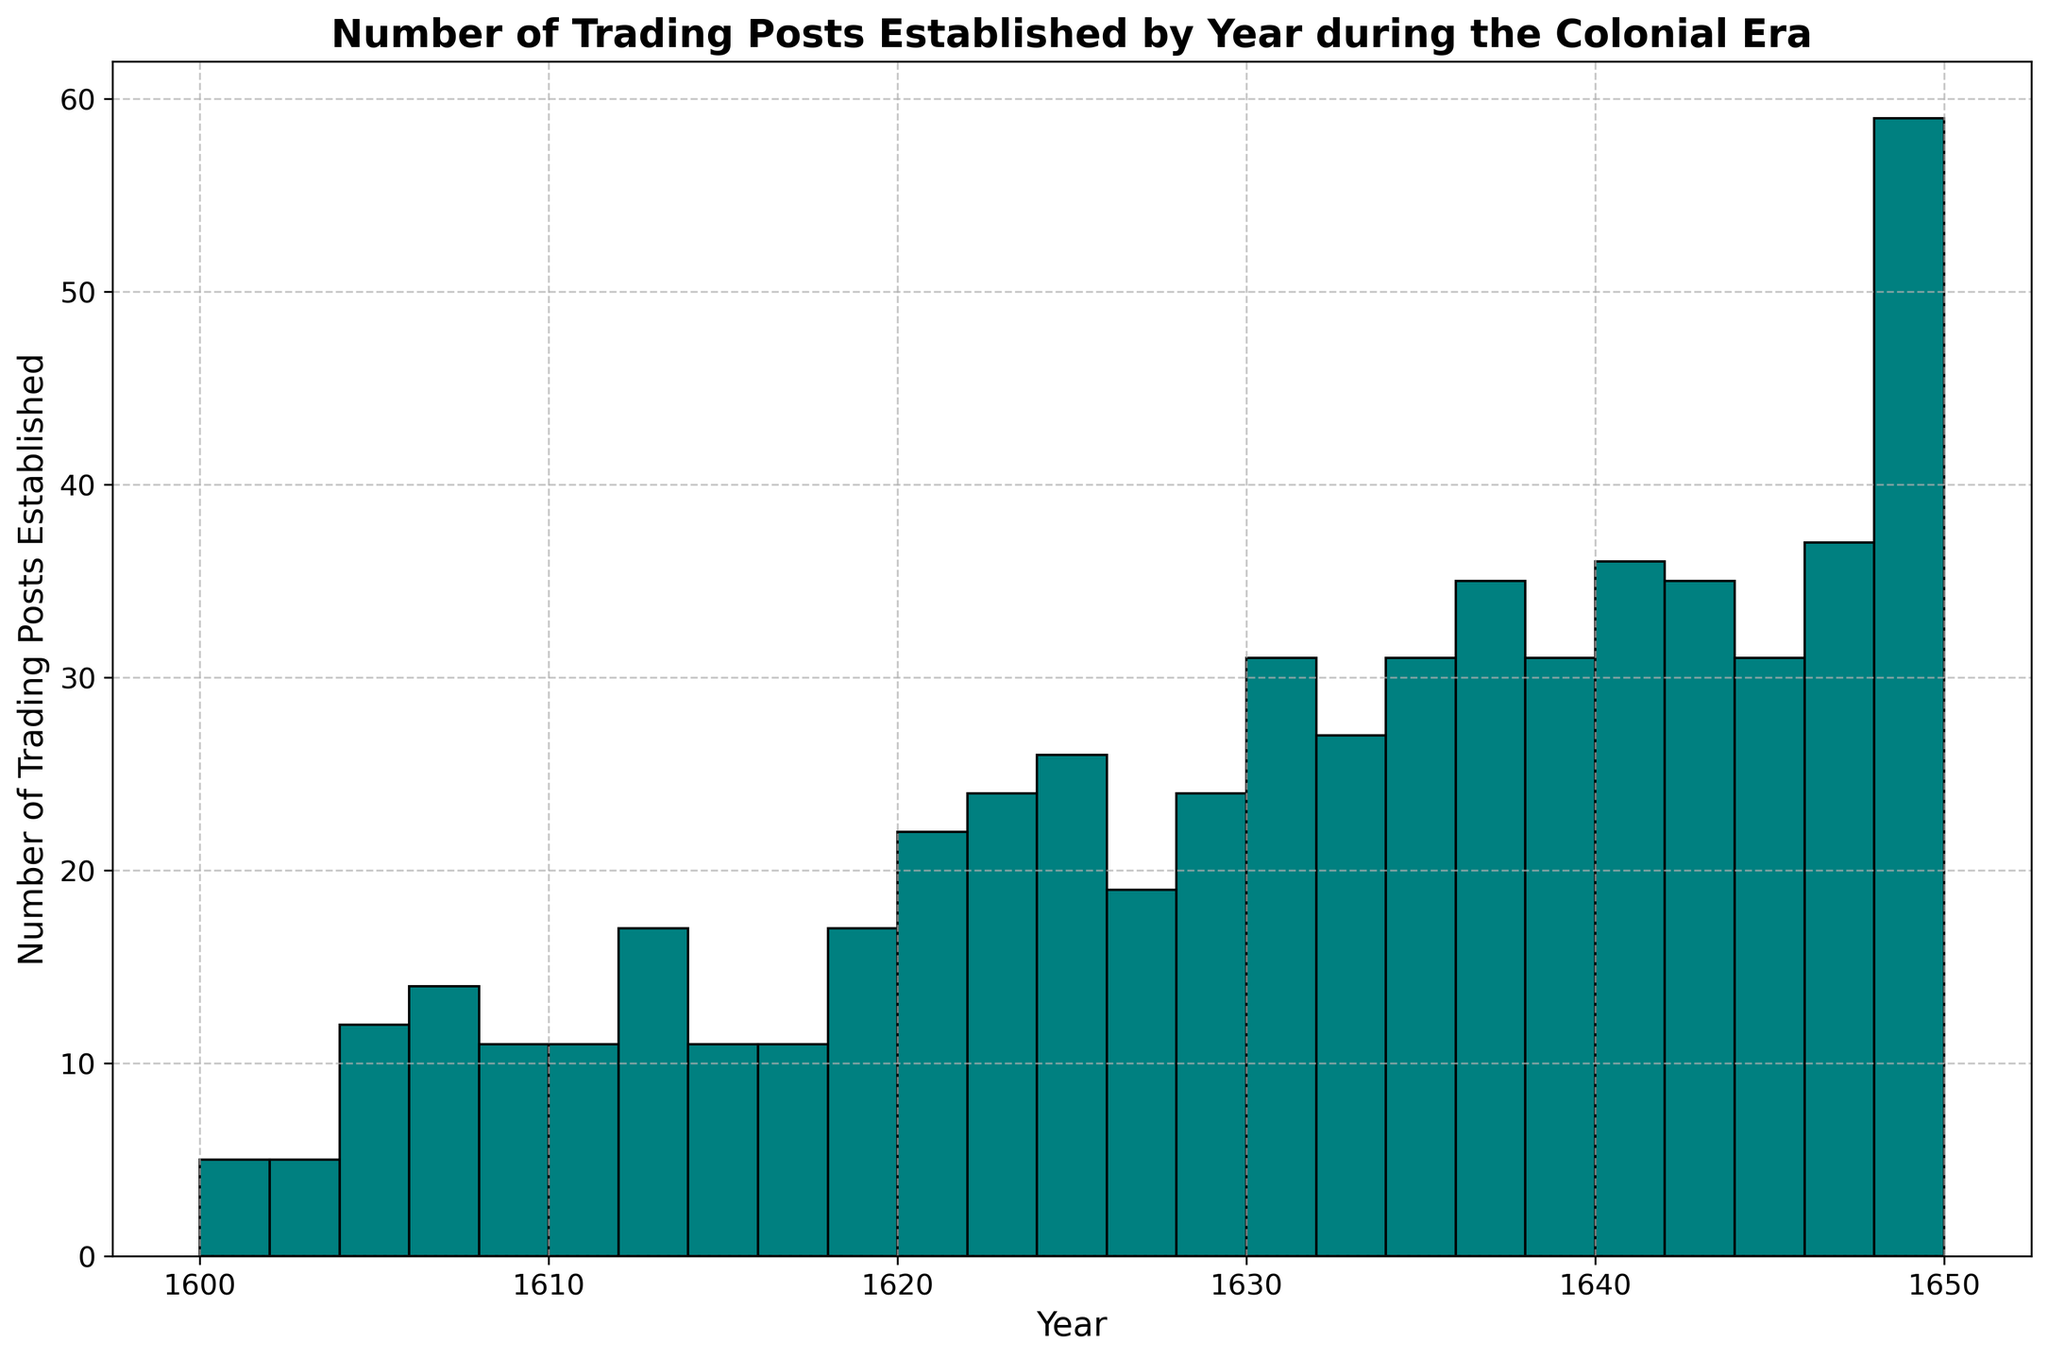What's the peak year for the establishment of trading posts? The histogram will show the year with the highest number of trading posts established, which appears as the tallest bar. This occurs around 1650.
Answer: 1650 Which year had the fewest number of trading posts established, and how many were established? The histogram displays the different bar heights representing the count of trading posts for each year. The shortest bar represents the fewest trading posts established, which is in the year 1602 with only 1 trading post.
Answer: 1602, 1 How many trading posts were established around the midpoint of the time frame? To find the midpoint, consider the average of the first and last years (1600 and 1650), which is 1625. Check the histogram around this year to estimate the number of trading posts, which is around 14 trading posts established.
Answer: 14 Are there any clusters or time periods with consistently high or low numbers of trading posts established? The histogram shows clusters where the number of trading posts continues at high or low counts over successive years. There is a cluster of high activity from about 1630 to 1650 with increasing numbers of trading posts.
Answer: 1630-1650 How does the number of trading posts established in the first half of the period (1600-1625) compare to the second half (1626-1650)? Sum the number of trading posts established from 1600 to 1625 and from 1626 to 1650. The histogram suggests more trading posts were established in the second half compared to the first half.
Answer: Second half > First half Which two consecutive years had the largest increase in the number of trading posts established? The histogram shows bar heights which help measure the increase between consecutive years. The largest increase appears between 1625 (14) and 1626 (10), showing a net increase of about 4 trading posts.
Answer: 1625-1626 What is the average number of trading posts established per year over the entire period? To calculate the average, find the total number of trading posts and divide it by the number of years (from 1600 to 1650, 51 years). The sum of trading posts is around 526, so the average is 526/51 ≈ 10.3.
Answer: 10.3 Which decade saw the most growth in trading post establishments? Observe the histogram for the decade with the most rapid increase in the number of trading posts. The 1640s shows significant growth with multiple high bars.
Answer: 1640s Is there any visual trend or pattern noticeable in the establishment of trading posts over time? The histogram shows the overall trend in bar heights, which generally increase as time progresses indicating that more trading posts were established over time. This suggests a growth trend.
Answer: Increasing trend 